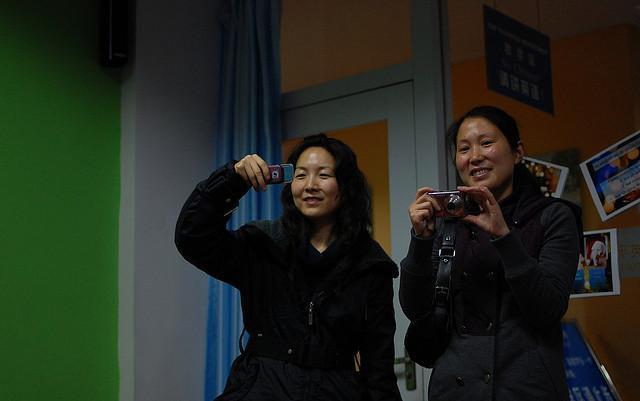How many women have a phone in use?
Give a very brief answer. 1. How many people are present for this photograph?
Give a very brief answer. 2. How many people in this picture are carrying bags?
Give a very brief answer. 1. How many people are there?
Give a very brief answer. 2. How many electronic devices is the person holding?
Give a very brief answer. 1. 